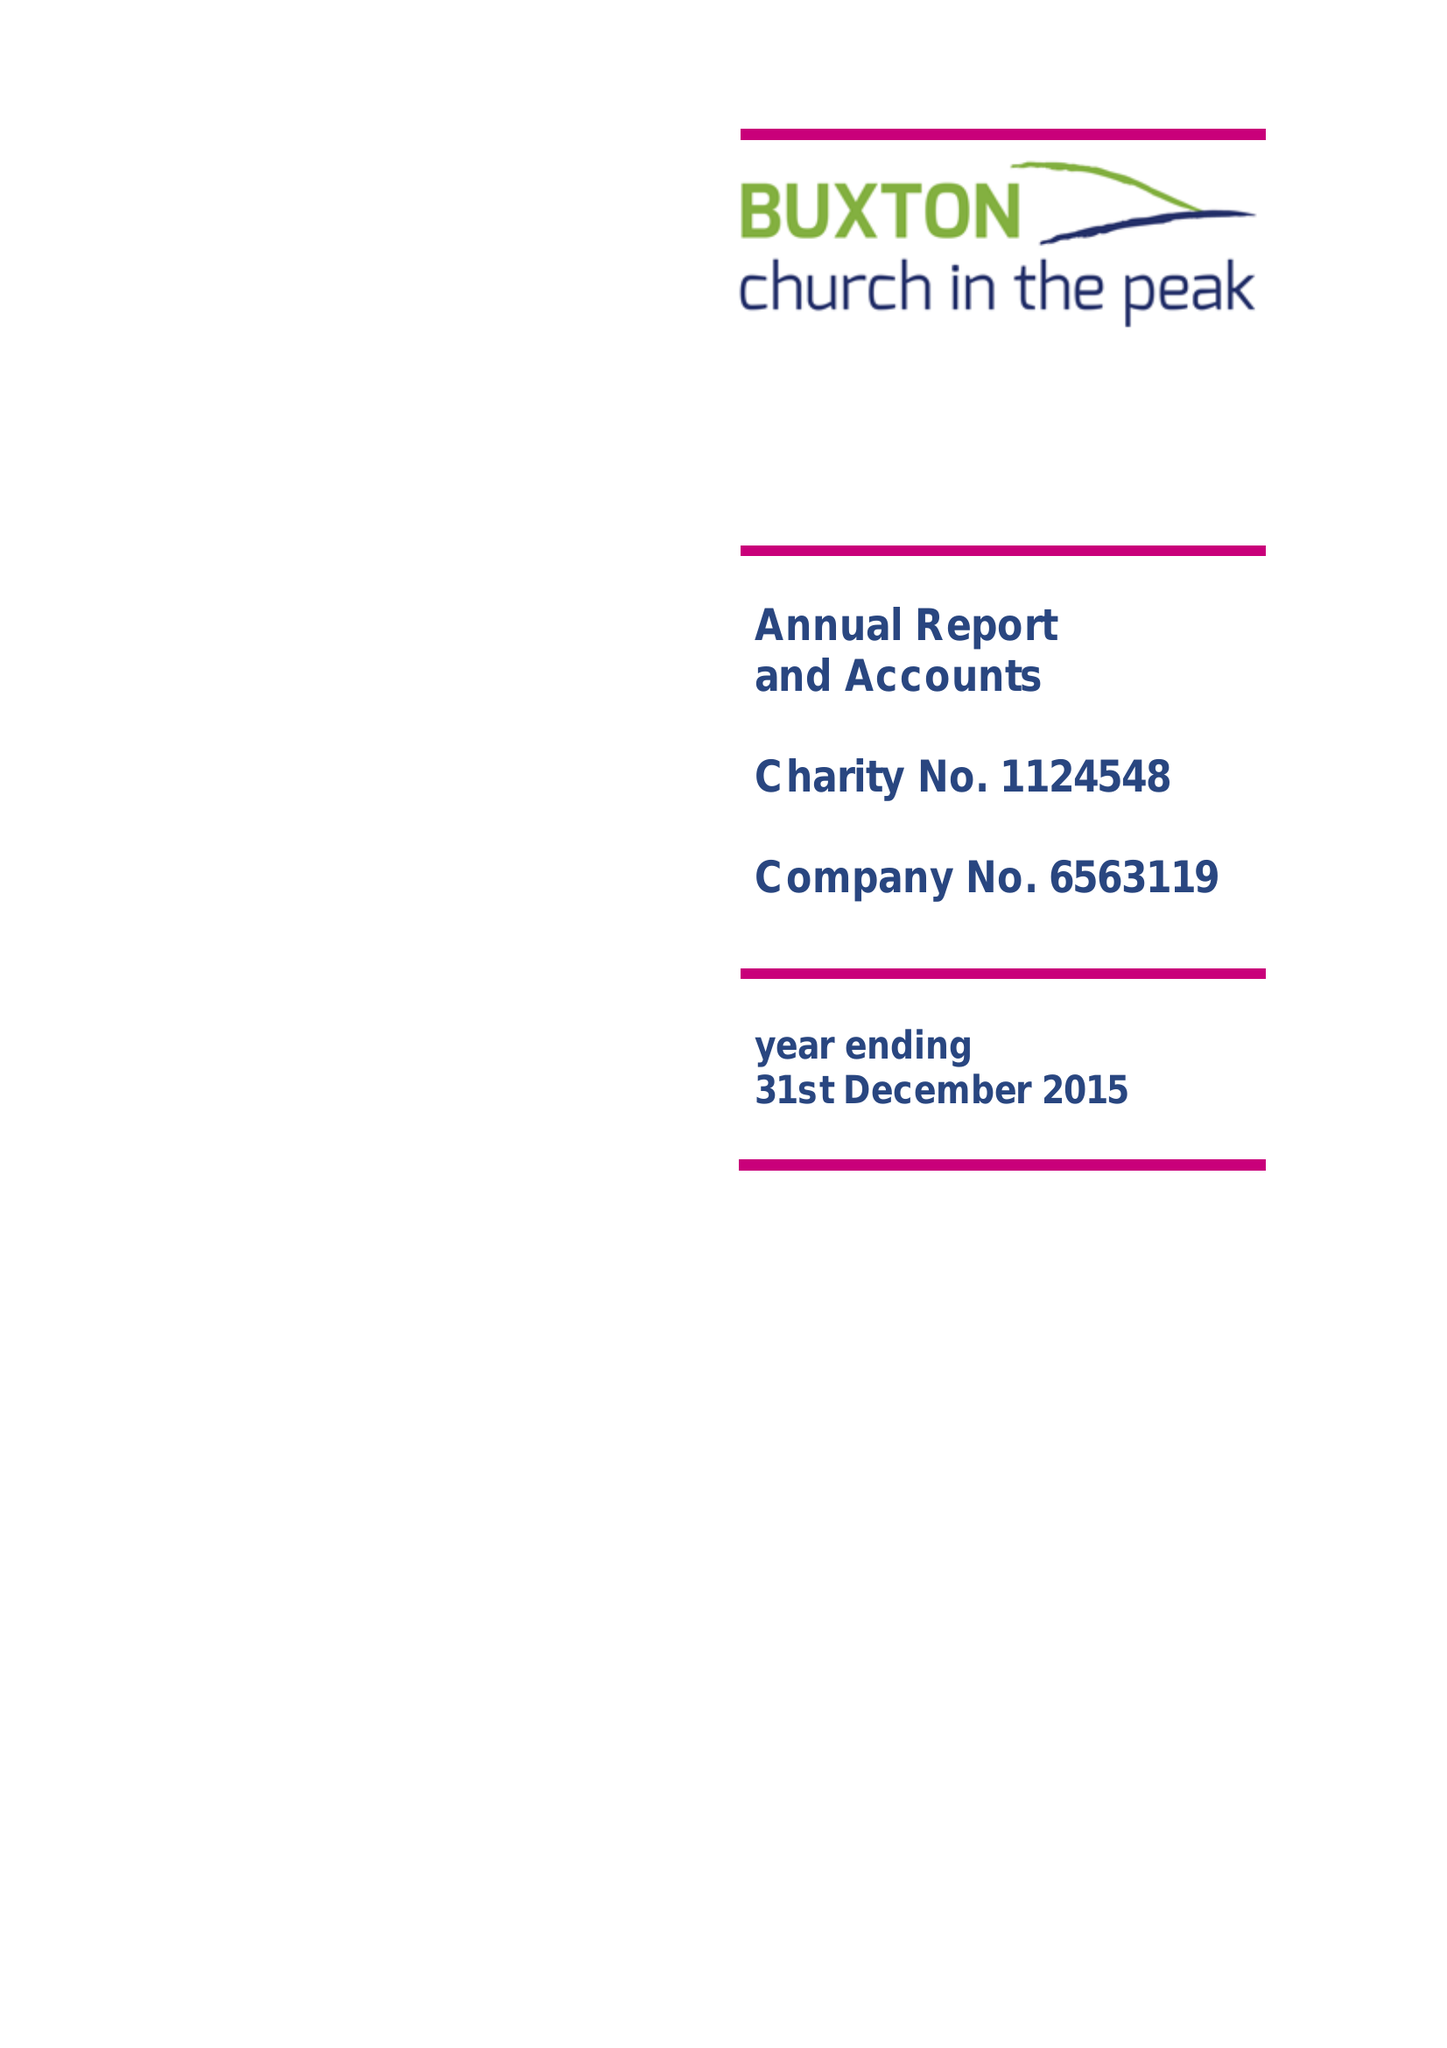What is the value for the address__postcode?
Answer the question using a single word or phrase. SK17 9AD 